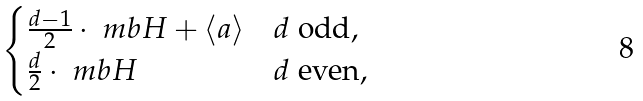Convert formula to latex. <formula><loc_0><loc_0><loc_500><loc_500>\begin{cases} \frac { d - 1 } { 2 } \cdot \ m b { H } + \langle a \rangle & d \text { odd} , \\ \frac { d } { 2 } \cdot \ m b { H } & d \text { even} , \end{cases}</formula> 